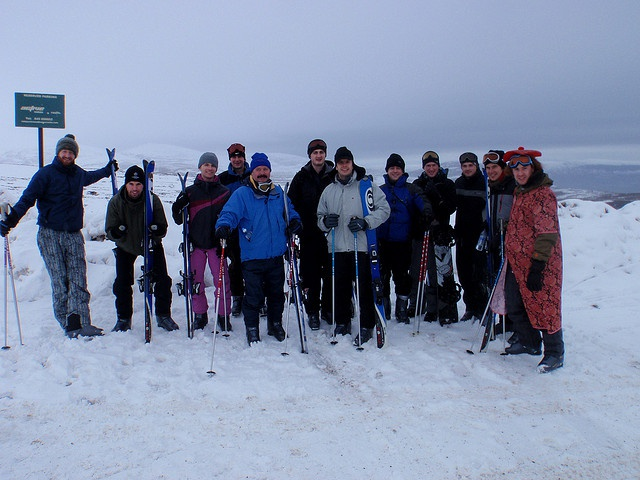Describe the objects in this image and their specific colors. I can see people in lavender, maroon, black, purple, and brown tones, people in lavender, black, navy, gray, and blue tones, people in lavender, black, darkblue, navy, and blue tones, people in lavender, black, and gray tones, and people in lavender, black, navy, maroon, and darkgray tones in this image. 